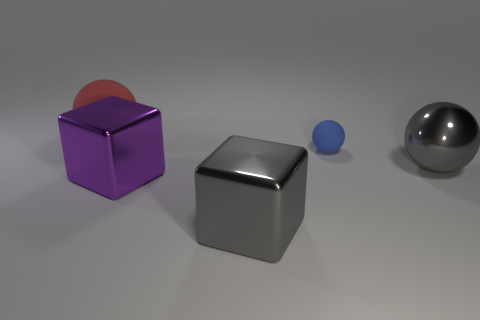Are there any other things that have the same size as the shiny ball?
Give a very brief answer. Yes. Are there more big gray shiny objects that are on the left side of the purple shiny thing than metal objects that are to the right of the gray ball?
Provide a short and direct response. No. Do the matte object that is on the right side of the red sphere and the big rubber ball have the same size?
Give a very brief answer. No. There is a matte ball in front of the rubber thing that is left of the blue rubber thing; what number of gray metallic spheres are to the left of it?
Your response must be concise. 0. What size is the thing that is both behind the purple cube and on the left side of the tiny thing?
Provide a short and direct response. Large. How many other objects are the same shape as the tiny blue thing?
Your response must be concise. 2. How many gray metal spheres are right of the metallic ball?
Provide a short and direct response. 0. Are there fewer big red objects on the right side of the gray block than small matte balls that are behind the blue rubber object?
Ensure brevity in your answer.  No. There is a big metallic thing that is to the right of the large gray metallic object in front of the ball that is in front of the blue ball; what shape is it?
Your answer should be compact. Sphere. There is a thing that is left of the tiny blue rubber object and behind the gray metal ball; what is its shape?
Provide a succinct answer. Sphere. 